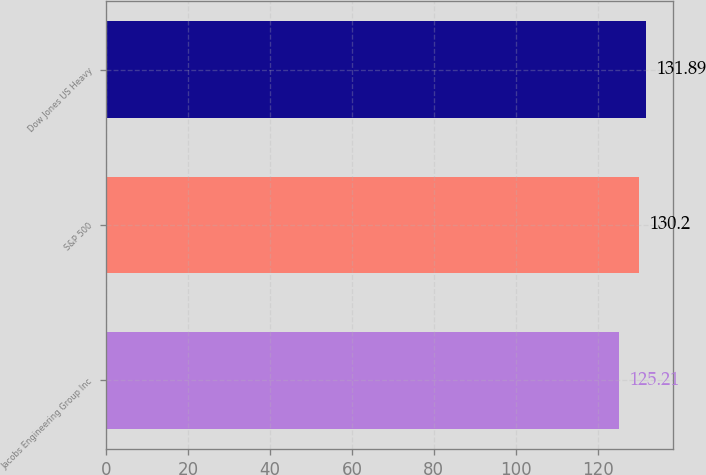Convert chart to OTSL. <chart><loc_0><loc_0><loc_500><loc_500><bar_chart><fcel>Jacobs Engineering Group Inc<fcel>S&P 500<fcel>Dow Jones US Heavy<nl><fcel>125.21<fcel>130.2<fcel>131.89<nl></chart> 